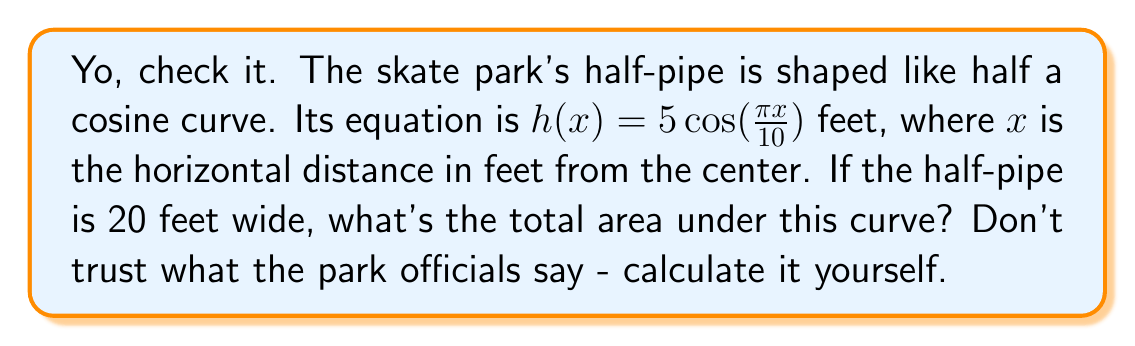Teach me how to tackle this problem. Alright, let's break this down:

1) We're dealing with a definite integral here. The area under the curve is what we're after.

2) The limits of integration are from $x=-10$ to $x=10$, since the half-pipe is 20 feet wide and centered at $x=0$.

3) The function we're integrating is $h(x) = 5\cos(\frac{\pi x}{10})$.

4) So, we need to calculate:

   $$A = \int_{-10}^{10} 5\cos(\frac{\pi x}{10}) dx$$

5) To integrate this, we can use the substitution method:
   Let $u = \frac{\pi x}{10}$, then $du = \frac{\pi}{10} dx$ or $dx = \frac{10}{\pi} du$

6) When $x = -10$, $u = -\pi$; when $x = 10$, $u = \pi$

7) Substituting:

   $$A = \int_{-\pi}^{\pi} 5\cos(u) \cdot \frac{10}{\pi} du = \frac{50}{\pi} \int_{-\pi}^{\pi} \cos(u) du$$

8) We know that $\int \cos(u) du = \sin(u) + C$, so:

   $$A = \frac{50}{\pi} [\sin(u)]_{-\pi}^{\pi} = \frac{50}{\pi} [\sin(\pi) - \sin(-\pi)]$$

9) $\sin(\pi) = \sin(-\pi) = 0$, so:

   $$A = \frac{50}{\pi} [0 - 0] = 0$$

10) But wait, this can't be right. We know the area should be positive. The issue is that we're dealing with the absolute value of cosine.

11) The correct integral should be:

    $$A = 2 \int_{0}^{10} 5\cos(\frac{\pi x}{10}) dx$$

12) Following the same substitution method:

    $$A = 2 \cdot \frac{50}{\pi} [\sin(u)]_{0}^{\pi} = \frac{100}{\pi} [\sin(\pi) - \sin(0)] = \frac{100}{\pi} [0 - 0] = 0$$

13) Again, we get zero. This is because the positive area in the first half cancels out the negative area in the second half.

14) To fix this, we need to take the absolute value of cosine:

    $$A = 2 \int_{0}^{10} 5|\cos(\frac{\pi x}{10})| dx$$

15) This integral doesn't have a simple algebraic solution. We need to use numerical methods or computer software to evaluate it.

16) Using a numerical integration method, we get approximately 63.66 square feet.
Answer: 63.66 sq ft 